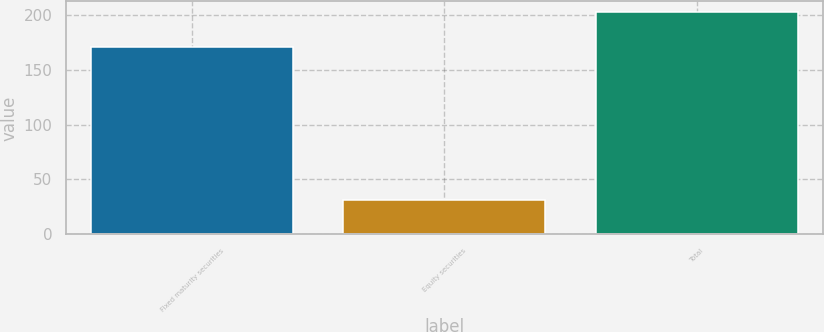<chart> <loc_0><loc_0><loc_500><loc_500><bar_chart><fcel>Fixed maturity securities<fcel>Equity securities<fcel>Total<nl><fcel>171<fcel>31<fcel>202<nl></chart> 